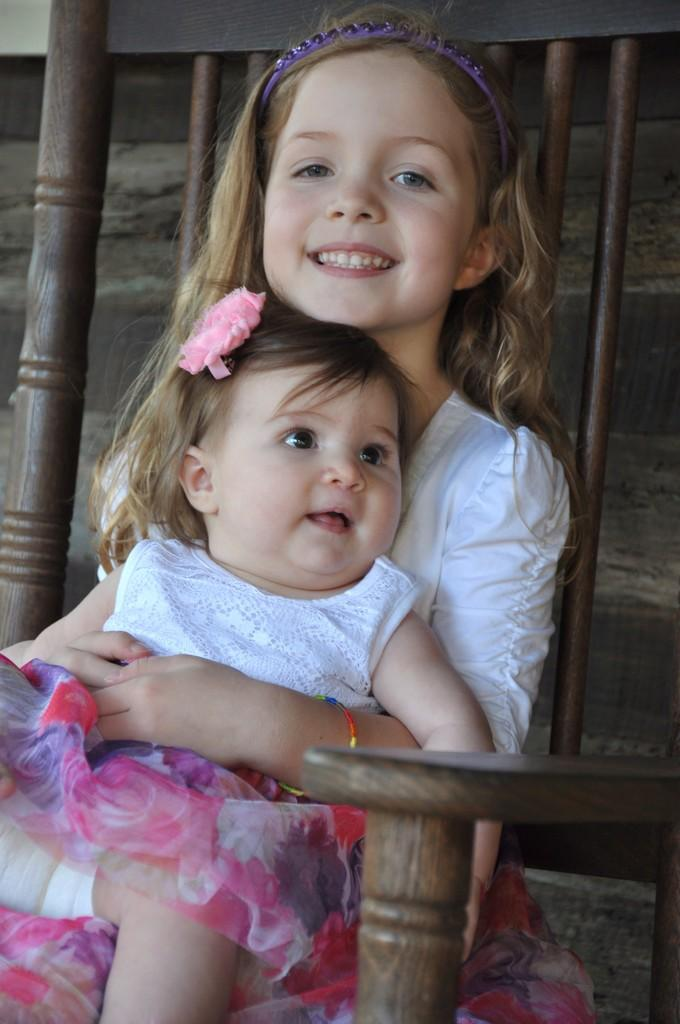How many people are in the image? There are two girls in the image. What are the girls doing in the image? The girls are sitting in a wooden chair and smiling. What can be seen in the background of the image? There appears to be a wall in the background of the image. What type of legal advice are the girls providing in the image? There is no indication in the image that the girls are providing legal advice or acting as lawyers. 